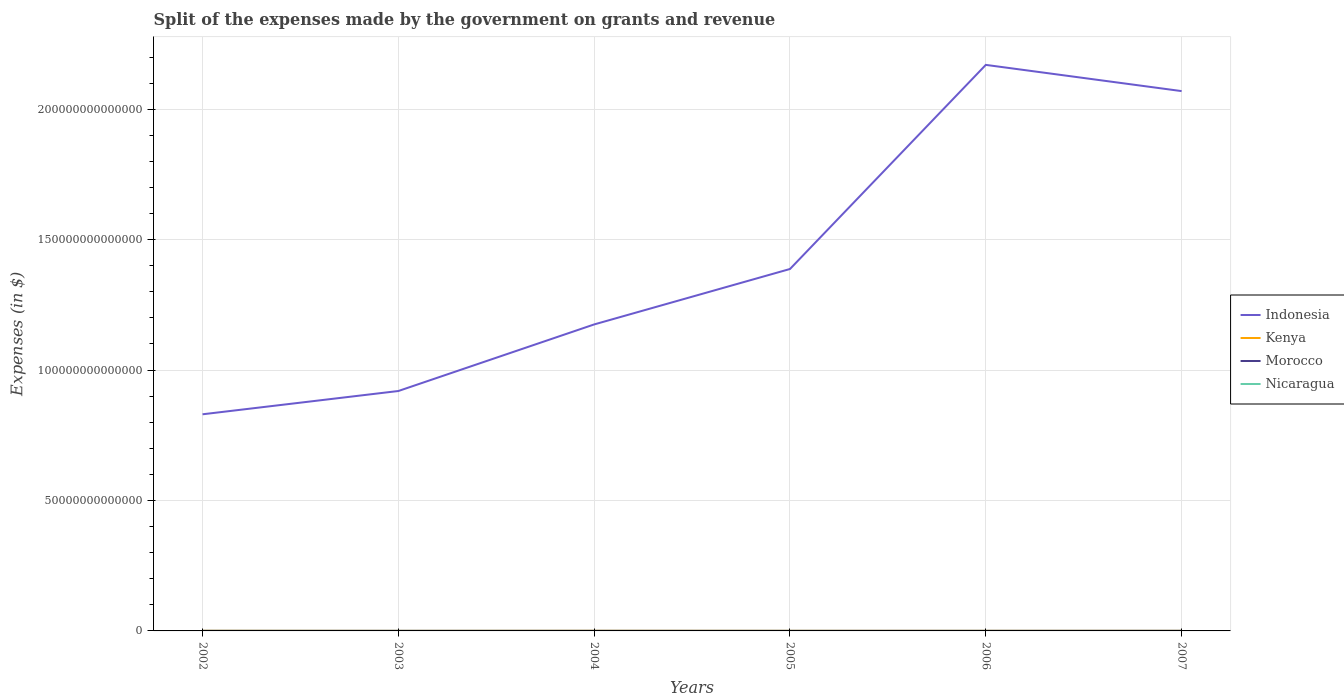How many different coloured lines are there?
Make the answer very short. 4. Does the line corresponding to Kenya intersect with the line corresponding to Nicaragua?
Offer a terse response. No. Across all years, what is the maximum expenses made by the government on grants and revenue in Morocco?
Your answer should be very brief. 2.56e+1. In which year was the expenses made by the government on grants and revenue in Nicaragua maximum?
Your answer should be compact. 2002. What is the total expenses made by the government on grants and revenue in Kenya in the graph?
Provide a succinct answer. 1.85e+1. What is the difference between the highest and the second highest expenses made by the government on grants and revenue in Indonesia?
Make the answer very short. 1.34e+14. What is the difference between the highest and the lowest expenses made by the government on grants and revenue in Nicaragua?
Offer a very short reply. 2. Is the expenses made by the government on grants and revenue in Kenya strictly greater than the expenses made by the government on grants and revenue in Nicaragua over the years?
Offer a terse response. No. How many lines are there?
Offer a very short reply. 4. What is the difference between two consecutive major ticks on the Y-axis?
Your response must be concise. 5.00e+13. What is the title of the graph?
Provide a succinct answer. Split of the expenses made by the government on grants and revenue. What is the label or title of the X-axis?
Keep it short and to the point. Years. What is the label or title of the Y-axis?
Your answer should be very brief. Expenses (in $). What is the Expenses (in $) in Indonesia in 2002?
Your response must be concise. 8.31e+13. What is the Expenses (in $) of Kenya in 2002?
Offer a very short reply. 5.49e+1. What is the Expenses (in $) in Morocco in 2002?
Your answer should be compact. 2.93e+1. What is the Expenses (in $) of Nicaragua in 2002?
Provide a succinct answer. 2.35e+09. What is the Expenses (in $) of Indonesia in 2003?
Provide a succinct answer. 9.20e+13. What is the Expenses (in $) of Kenya in 2003?
Your response must be concise. 2.51e+1. What is the Expenses (in $) in Morocco in 2003?
Provide a short and direct response. 2.68e+1. What is the Expenses (in $) of Nicaragua in 2003?
Your answer should be very brief. 2.81e+09. What is the Expenses (in $) of Indonesia in 2004?
Offer a very short reply. 1.17e+14. What is the Expenses (in $) in Kenya in 2004?
Make the answer very short. 5.44e+1. What is the Expenses (in $) of Morocco in 2004?
Your answer should be very brief. 3.17e+1. What is the Expenses (in $) in Nicaragua in 2004?
Provide a succinct answer. 3.35e+09. What is the Expenses (in $) in Indonesia in 2005?
Give a very brief answer. 1.39e+14. What is the Expenses (in $) of Kenya in 2005?
Ensure brevity in your answer.  3.64e+1. What is the Expenses (in $) of Morocco in 2005?
Your answer should be compact. 2.56e+1. What is the Expenses (in $) of Nicaragua in 2005?
Keep it short and to the point. 3.79e+09. What is the Expenses (in $) of Indonesia in 2006?
Ensure brevity in your answer.  2.17e+14. What is the Expenses (in $) of Kenya in 2006?
Make the answer very short. 3.59e+1. What is the Expenses (in $) of Morocco in 2006?
Your response must be concise. 3.04e+1. What is the Expenses (in $) in Nicaragua in 2006?
Provide a short and direct response. 4.94e+09. What is the Expenses (in $) in Indonesia in 2007?
Your answer should be compact. 2.07e+14. What is the Expenses (in $) of Kenya in 2007?
Make the answer very short. 3.28e+1. What is the Expenses (in $) of Morocco in 2007?
Make the answer very short. 3.32e+1. What is the Expenses (in $) in Nicaragua in 2007?
Make the answer very short. 5.51e+09. Across all years, what is the maximum Expenses (in $) of Indonesia?
Offer a terse response. 2.17e+14. Across all years, what is the maximum Expenses (in $) of Kenya?
Your response must be concise. 5.49e+1. Across all years, what is the maximum Expenses (in $) of Morocco?
Your answer should be compact. 3.32e+1. Across all years, what is the maximum Expenses (in $) of Nicaragua?
Offer a very short reply. 5.51e+09. Across all years, what is the minimum Expenses (in $) of Indonesia?
Your answer should be compact. 8.31e+13. Across all years, what is the minimum Expenses (in $) in Kenya?
Keep it short and to the point. 2.51e+1. Across all years, what is the minimum Expenses (in $) of Morocco?
Offer a terse response. 2.56e+1. Across all years, what is the minimum Expenses (in $) in Nicaragua?
Your response must be concise. 2.35e+09. What is the total Expenses (in $) in Indonesia in the graph?
Provide a succinct answer. 8.55e+14. What is the total Expenses (in $) of Kenya in the graph?
Your answer should be very brief. 2.40e+11. What is the total Expenses (in $) in Morocco in the graph?
Make the answer very short. 1.77e+11. What is the total Expenses (in $) of Nicaragua in the graph?
Make the answer very short. 2.27e+1. What is the difference between the Expenses (in $) in Indonesia in 2002 and that in 2003?
Keep it short and to the point. -8.92e+12. What is the difference between the Expenses (in $) in Kenya in 2002 and that in 2003?
Provide a succinct answer. 2.98e+1. What is the difference between the Expenses (in $) in Morocco in 2002 and that in 2003?
Provide a short and direct response. 2.50e+09. What is the difference between the Expenses (in $) in Nicaragua in 2002 and that in 2003?
Offer a terse response. -4.61e+08. What is the difference between the Expenses (in $) of Indonesia in 2002 and that in 2004?
Provide a short and direct response. -3.44e+13. What is the difference between the Expenses (in $) in Kenya in 2002 and that in 2004?
Offer a very short reply. 5.57e+08. What is the difference between the Expenses (in $) of Morocco in 2002 and that in 2004?
Provide a short and direct response. -2.42e+09. What is the difference between the Expenses (in $) of Nicaragua in 2002 and that in 2004?
Make the answer very short. -1.01e+09. What is the difference between the Expenses (in $) of Indonesia in 2002 and that in 2005?
Make the answer very short. -5.57e+13. What is the difference between the Expenses (in $) in Kenya in 2002 and that in 2005?
Provide a short and direct response. 1.85e+1. What is the difference between the Expenses (in $) of Morocco in 2002 and that in 2005?
Offer a terse response. 3.67e+09. What is the difference between the Expenses (in $) of Nicaragua in 2002 and that in 2005?
Offer a terse response. -1.44e+09. What is the difference between the Expenses (in $) of Indonesia in 2002 and that in 2006?
Offer a very short reply. -1.34e+14. What is the difference between the Expenses (in $) of Kenya in 2002 and that in 2006?
Give a very brief answer. 1.90e+1. What is the difference between the Expenses (in $) in Morocco in 2002 and that in 2006?
Provide a succinct answer. -1.04e+09. What is the difference between the Expenses (in $) in Nicaragua in 2002 and that in 2006?
Keep it short and to the point. -2.60e+09. What is the difference between the Expenses (in $) in Indonesia in 2002 and that in 2007?
Your response must be concise. -1.24e+14. What is the difference between the Expenses (in $) in Kenya in 2002 and that in 2007?
Offer a very short reply. 2.21e+1. What is the difference between the Expenses (in $) in Morocco in 2002 and that in 2007?
Provide a succinct answer. -3.87e+09. What is the difference between the Expenses (in $) in Nicaragua in 2002 and that in 2007?
Keep it short and to the point. -3.16e+09. What is the difference between the Expenses (in $) of Indonesia in 2003 and that in 2004?
Offer a very short reply. -2.55e+13. What is the difference between the Expenses (in $) in Kenya in 2003 and that in 2004?
Keep it short and to the point. -2.93e+1. What is the difference between the Expenses (in $) in Morocco in 2003 and that in 2004?
Ensure brevity in your answer.  -4.92e+09. What is the difference between the Expenses (in $) in Nicaragua in 2003 and that in 2004?
Give a very brief answer. -5.44e+08. What is the difference between the Expenses (in $) in Indonesia in 2003 and that in 2005?
Provide a succinct answer. -4.68e+13. What is the difference between the Expenses (in $) of Kenya in 2003 and that in 2005?
Offer a very short reply. -1.13e+1. What is the difference between the Expenses (in $) of Morocco in 2003 and that in 2005?
Your answer should be very brief. 1.17e+09. What is the difference between the Expenses (in $) in Nicaragua in 2003 and that in 2005?
Keep it short and to the point. -9.78e+08. What is the difference between the Expenses (in $) in Indonesia in 2003 and that in 2006?
Offer a very short reply. -1.25e+14. What is the difference between the Expenses (in $) in Kenya in 2003 and that in 2006?
Offer a terse response. -1.08e+1. What is the difference between the Expenses (in $) of Morocco in 2003 and that in 2006?
Give a very brief answer. -3.54e+09. What is the difference between the Expenses (in $) in Nicaragua in 2003 and that in 2006?
Offer a very short reply. -2.14e+09. What is the difference between the Expenses (in $) in Indonesia in 2003 and that in 2007?
Offer a very short reply. -1.15e+14. What is the difference between the Expenses (in $) of Kenya in 2003 and that in 2007?
Make the answer very short. -7.73e+09. What is the difference between the Expenses (in $) in Morocco in 2003 and that in 2007?
Make the answer very short. -6.37e+09. What is the difference between the Expenses (in $) of Nicaragua in 2003 and that in 2007?
Your response must be concise. -2.70e+09. What is the difference between the Expenses (in $) in Indonesia in 2004 and that in 2005?
Offer a very short reply. -2.13e+13. What is the difference between the Expenses (in $) of Kenya in 2004 and that in 2005?
Ensure brevity in your answer.  1.80e+1. What is the difference between the Expenses (in $) in Morocco in 2004 and that in 2005?
Offer a very short reply. 6.10e+09. What is the difference between the Expenses (in $) of Nicaragua in 2004 and that in 2005?
Provide a short and direct response. -4.34e+08. What is the difference between the Expenses (in $) of Indonesia in 2004 and that in 2006?
Give a very brief answer. -9.95e+13. What is the difference between the Expenses (in $) of Kenya in 2004 and that in 2006?
Your answer should be very brief. 1.85e+1. What is the difference between the Expenses (in $) of Morocco in 2004 and that in 2006?
Offer a very short reply. 1.38e+09. What is the difference between the Expenses (in $) in Nicaragua in 2004 and that in 2006?
Your answer should be compact. -1.59e+09. What is the difference between the Expenses (in $) in Indonesia in 2004 and that in 2007?
Offer a terse response. -8.95e+13. What is the difference between the Expenses (in $) in Kenya in 2004 and that in 2007?
Give a very brief answer. 2.15e+1. What is the difference between the Expenses (in $) in Morocco in 2004 and that in 2007?
Your answer should be compact. -1.44e+09. What is the difference between the Expenses (in $) of Nicaragua in 2004 and that in 2007?
Your answer should be very brief. -2.15e+09. What is the difference between the Expenses (in $) of Indonesia in 2005 and that in 2006?
Offer a terse response. -7.83e+13. What is the difference between the Expenses (in $) in Kenya in 2005 and that in 2006?
Offer a terse response. 5.04e+08. What is the difference between the Expenses (in $) of Morocco in 2005 and that in 2006?
Your response must be concise. -4.72e+09. What is the difference between the Expenses (in $) of Nicaragua in 2005 and that in 2006?
Ensure brevity in your answer.  -1.16e+09. What is the difference between the Expenses (in $) in Indonesia in 2005 and that in 2007?
Your answer should be compact. -6.82e+13. What is the difference between the Expenses (in $) in Kenya in 2005 and that in 2007?
Make the answer very short. 3.58e+09. What is the difference between the Expenses (in $) of Morocco in 2005 and that in 2007?
Offer a very short reply. -7.54e+09. What is the difference between the Expenses (in $) of Nicaragua in 2005 and that in 2007?
Provide a succinct answer. -1.72e+09. What is the difference between the Expenses (in $) in Indonesia in 2006 and that in 2007?
Offer a terse response. 1.01e+13. What is the difference between the Expenses (in $) of Kenya in 2006 and that in 2007?
Keep it short and to the point. 3.07e+09. What is the difference between the Expenses (in $) in Morocco in 2006 and that in 2007?
Ensure brevity in your answer.  -2.82e+09. What is the difference between the Expenses (in $) of Nicaragua in 2006 and that in 2007?
Make the answer very short. -5.64e+08. What is the difference between the Expenses (in $) of Indonesia in 2002 and the Expenses (in $) of Kenya in 2003?
Offer a terse response. 8.30e+13. What is the difference between the Expenses (in $) in Indonesia in 2002 and the Expenses (in $) in Morocco in 2003?
Offer a very short reply. 8.30e+13. What is the difference between the Expenses (in $) of Indonesia in 2002 and the Expenses (in $) of Nicaragua in 2003?
Make the answer very short. 8.30e+13. What is the difference between the Expenses (in $) in Kenya in 2002 and the Expenses (in $) in Morocco in 2003?
Your response must be concise. 2.81e+1. What is the difference between the Expenses (in $) in Kenya in 2002 and the Expenses (in $) in Nicaragua in 2003?
Provide a short and direct response. 5.21e+1. What is the difference between the Expenses (in $) of Morocco in 2002 and the Expenses (in $) of Nicaragua in 2003?
Give a very brief answer. 2.65e+1. What is the difference between the Expenses (in $) in Indonesia in 2002 and the Expenses (in $) in Kenya in 2004?
Keep it short and to the point. 8.30e+13. What is the difference between the Expenses (in $) in Indonesia in 2002 and the Expenses (in $) in Morocco in 2004?
Keep it short and to the point. 8.30e+13. What is the difference between the Expenses (in $) of Indonesia in 2002 and the Expenses (in $) of Nicaragua in 2004?
Your answer should be very brief. 8.30e+13. What is the difference between the Expenses (in $) of Kenya in 2002 and the Expenses (in $) of Morocco in 2004?
Make the answer very short. 2.32e+1. What is the difference between the Expenses (in $) in Kenya in 2002 and the Expenses (in $) in Nicaragua in 2004?
Your response must be concise. 5.16e+1. What is the difference between the Expenses (in $) in Morocco in 2002 and the Expenses (in $) in Nicaragua in 2004?
Your answer should be very brief. 2.60e+1. What is the difference between the Expenses (in $) of Indonesia in 2002 and the Expenses (in $) of Kenya in 2005?
Ensure brevity in your answer.  8.30e+13. What is the difference between the Expenses (in $) in Indonesia in 2002 and the Expenses (in $) in Morocco in 2005?
Ensure brevity in your answer.  8.30e+13. What is the difference between the Expenses (in $) of Indonesia in 2002 and the Expenses (in $) of Nicaragua in 2005?
Ensure brevity in your answer.  8.30e+13. What is the difference between the Expenses (in $) of Kenya in 2002 and the Expenses (in $) of Morocco in 2005?
Offer a terse response. 2.93e+1. What is the difference between the Expenses (in $) of Kenya in 2002 and the Expenses (in $) of Nicaragua in 2005?
Provide a short and direct response. 5.12e+1. What is the difference between the Expenses (in $) of Morocco in 2002 and the Expenses (in $) of Nicaragua in 2005?
Offer a terse response. 2.55e+1. What is the difference between the Expenses (in $) in Indonesia in 2002 and the Expenses (in $) in Kenya in 2006?
Offer a terse response. 8.30e+13. What is the difference between the Expenses (in $) of Indonesia in 2002 and the Expenses (in $) of Morocco in 2006?
Ensure brevity in your answer.  8.30e+13. What is the difference between the Expenses (in $) of Indonesia in 2002 and the Expenses (in $) of Nicaragua in 2006?
Your answer should be very brief. 8.30e+13. What is the difference between the Expenses (in $) of Kenya in 2002 and the Expenses (in $) of Morocco in 2006?
Your response must be concise. 2.46e+1. What is the difference between the Expenses (in $) of Kenya in 2002 and the Expenses (in $) of Nicaragua in 2006?
Provide a succinct answer. 5.00e+1. What is the difference between the Expenses (in $) in Morocco in 2002 and the Expenses (in $) in Nicaragua in 2006?
Give a very brief answer. 2.44e+1. What is the difference between the Expenses (in $) of Indonesia in 2002 and the Expenses (in $) of Kenya in 2007?
Provide a succinct answer. 8.30e+13. What is the difference between the Expenses (in $) in Indonesia in 2002 and the Expenses (in $) in Morocco in 2007?
Make the answer very short. 8.30e+13. What is the difference between the Expenses (in $) in Indonesia in 2002 and the Expenses (in $) in Nicaragua in 2007?
Offer a terse response. 8.30e+13. What is the difference between the Expenses (in $) of Kenya in 2002 and the Expenses (in $) of Morocco in 2007?
Give a very brief answer. 2.18e+1. What is the difference between the Expenses (in $) of Kenya in 2002 and the Expenses (in $) of Nicaragua in 2007?
Give a very brief answer. 4.94e+1. What is the difference between the Expenses (in $) of Morocco in 2002 and the Expenses (in $) of Nicaragua in 2007?
Your answer should be compact. 2.38e+1. What is the difference between the Expenses (in $) in Indonesia in 2003 and the Expenses (in $) in Kenya in 2004?
Ensure brevity in your answer.  9.19e+13. What is the difference between the Expenses (in $) of Indonesia in 2003 and the Expenses (in $) of Morocco in 2004?
Keep it short and to the point. 9.19e+13. What is the difference between the Expenses (in $) of Indonesia in 2003 and the Expenses (in $) of Nicaragua in 2004?
Ensure brevity in your answer.  9.20e+13. What is the difference between the Expenses (in $) of Kenya in 2003 and the Expenses (in $) of Morocco in 2004?
Offer a terse response. -6.63e+09. What is the difference between the Expenses (in $) of Kenya in 2003 and the Expenses (in $) of Nicaragua in 2004?
Provide a succinct answer. 2.18e+1. What is the difference between the Expenses (in $) of Morocco in 2003 and the Expenses (in $) of Nicaragua in 2004?
Make the answer very short. 2.35e+1. What is the difference between the Expenses (in $) of Indonesia in 2003 and the Expenses (in $) of Kenya in 2005?
Make the answer very short. 9.19e+13. What is the difference between the Expenses (in $) in Indonesia in 2003 and the Expenses (in $) in Morocco in 2005?
Offer a very short reply. 9.19e+13. What is the difference between the Expenses (in $) of Indonesia in 2003 and the Expenses (in $) of Nicaragua in 2005?
Your answer should be very brief. 9.20e+13. What is the difference between the Expenses (in $) of Kenya in 2003 and the Expenses (in $) of Morocco in 2005?
Ensure brevity in your answer.  -5.30e+08. What is the difference between the Expenses (in $) of Kenya in 2003 and the Expenses (in $) of Nicaragua in 2005?
Make the answer very short. 2.13e+1. What is the difference between the Expenses (in $) in Morocco in 2003 and the Expenses (in $) in Nicaragua in 2005?
Offer a terse response. 2.30e+1. What is the difference between the Expenses (in $) of Indonesia in 2003 and the Expenses (in $) of Kenya in 2006?
Provide a short and direct response. 9.19e+13. What is the difference between the Expenses (in $) of Indonesia in 2003 and the Expenses (in $) of Morocco in 2006?
Keep it short and to the point. 9.19e+13. What is the difference between the Expenses (in $) of Indonesia in 2003 and the Expenses (in $) of Nicaragua in 2006?
Your response must be concise. 9.20e+13. What is the difference between the Expenses (in $) of Kenya in 2003 and the Expenses (in $) of Morocco in 2006?
Offer a very short reply. -5.25e+09. What is the difference between the Expenses (in $) in Kenya in 2003 and the Expenses (in $) in Nicaragua in 2006?
Provide a short and direct response. 2.02e+1. What is the difference between the Expenses (in $) in Morocco in 2003 and the Expenses (in $) in Nicaragua in 2006?
Make the answer very short. 2.19e+1. What is the difference between the Expenses (in $) in Indonesia in 2003 and the Expenses (in $) in Kenya in 2007?
Give a very brief answer. 9.19e+13. What is the difference between the Expenses (in $) in Indonesia in 2003 and the Expenses (in $) in Morocco in 2007?
Offer a terse response. 9.19e+13. What is the difference between the Expenses (in $) of Indonesia in 2003 and the Expenses (in $) of Nicaragua in 2007?
Provide a short and direct response. 9.20e+13. What is the difference between the Expenses (in $) of Kenya in 2003 and the Expenses (in $) of Morocco in 2007?
Provide a succinct answer. -8.07e+09. What is the difference between the Expenses (in $) in Kenya in 2003 and the Expenses (in $) in Nicaragua in 2007?
Your answer should be very brief. 1.96e+1. What is the difference between the Expenses (in $) of Morocco in 2003 and the Expenses (in $) of Nicaragua in 2007?
Your answer should be compact. 2.13e+1. What is the difference between the Expenses (in $) of Indonesia in 2004 and the Expenses (in $) of Kenya in 2005?
Make the answer very short. 1.17e+14. What is the difference between the Expenses (in $) of Indonesia in 2004 and the Expenses (in $) of Morocco in 2005?
Your response must be concise. 1.17e+14. What is the difference between the Expenses (in $) in Indonesia in 2004 and the Expenses (in $) in Nicaragua in 2005?
Make the answer very short. 1.17e+14. What is the difference between the Expenses (in $) in Kenya in 2004 and the Expenses (in $) in Morocco in 2005?
Give a very brief answer. 2.88e+1. What is the difference between the Expenses (in $) in Kenya in 2004 and the Expenses (in $) in Nicaragua in 2005?
Offer a terse response. 5.06e+1. What is the difference between the Expenses (in $) in Morocco in 2004 and the Expenses (in $) in Nicaragua in 2005?
Offer a very short reply. 2.80e+1. What is the difference between the Expenses (in $) of Indonesia in 2004 and the Expenses (in $) of Kenya in 2006?
Provide a succinct answer. 1.17e+14. What is the difference between the Expenses (in $) of Indonesia in 2004 and the Expenses (in $) of Morocco in 2006?
Provide a short and direct response. 1.17e+14. What is the difference between the Expenses (in $) of Indonesia in 2004 and the Expenses (in $) of Nicaragua in 2006?
Offer a very short reply. 1.17e+14. What is the difference between the Expenses (in $) in Kenya in 2004 and the Expenses (in $) in Morocco in 2006?
Make the answer very short. 2.40e+1. What is the difference between the Expenses (in $) in Kenya in 2004 and the Expenses (in $) in Nicaragua in 2006?
Your response must be concise. 4.94e+1. What is the difference between the Expenses (in $) in Morocco in 2004 and the Expenses (in $) in Nicaragua in 2006?
Make the answer very short. 2.68e+1. What is the difference between the Expenses (in $) of Indonesia in 2004 and the Expenses (in $) of Kenya in 2007?
Offer a terse response. 1.17e+14. What is the difference between the Expenses (in $) of Indonesia in 2004 and the Expenses (in $) of Morocco in 2007?
Ensure brevity in your answer.  1.17e+14. What is the difference between the Expenses (in $) in Indonesia in 2004 and the Expenses (in $) in Nicaragua in 2007?
Your answer should be compact. 1.17e+14. What is the difference between the Expenses (in $) in Kenya in 2004 and the Expenses (in $) in Morocco in 2007?
Offer a terse response. 2.12e+1. What is the difference between the Expenses (in $) of Kenya in 2004 and the Expenses (in $) of Nicaragua in 2007?
Give a very brief answer. 4.89e+1. What is the difference between the Expenses (in $) of Morocco in 2004 and the Expenses (in $) of Nicaragua in 2007?
Your response must be concise. 2.62e+1. What is the difference between the Expenses (in $) in Indonesia in 2005 and the Expenses (in $) in Kenya in 2006?
Offer a terse response. 1.39e+14. What is the difference between the Expenses (in $) in Indonesia in 2005 and the Expenses (in $) in Morocco in 2006?
Keep it short and to the point. 1.39e+14. What is the difference between the Expenses (in $) of Indonesia in 2005 and the Expenses (in $) of Nicaragua in 2006?
Ensure brevity in your answer.  1.39e+14. What is the difference between the Expenses (in $) in Kenya in 2005 and the Expenses (in $) in Morocco in 2006?
Offer a very short reply. 6.06e+09. What is the difference between the Expenses (in $) in Kenya in 2005 and the Expenses (in $) in Nicaragua in 2006?
Offer a terse response. 3.15e+1. What is the difference between the Expenses (in $) in Morocco in 2005 and the Expenses (in $) in Nicaragua in 2006?
Offer a very short reply. 2.07e+1. What is the difference between the Expenses (in $) of Indonesia in 2005 and the Expenses (in $) of Kenya in 2007?
Give a very brief answer. 1.39e+14. What is the difference between the Expenses (in $) of Indonesia in 2005 and the Expenses (in $) of Morocco in 2007?
Ensure brevity in your answer.  1.39e+14. What is the difference between the Expenses (in $) in Indonesia in 2005 and the Expenses (in $) in Nicaragua in 2007?
Your answer should be compact. 1.39e+14. What is the difference between the Expenses (in $) in Kenya in 2005 and the Expenses (in $) in Morocco in 2007?
Give a very brief answer. 3.24e+09. What is the difference between the Expenses (in $) in Kenya in 2005 and the Expenses (in $) in Nicaragua in 2007?
Offer a very short reply. 3.09e+1. What is the difference between the Expenses (in $) of Morocco in 2005 and the Expenses (in $) of Nicaragua in 2007?
Give a very brief answer. 2.01e+1. What is the difference between the Expenses (in $) in Indonesia in 2006 and the Expenses (in $) in Kenya in 2007?
Your response must be concise. 2.17e+14. What is the difference between the Expenses (in $) of Indonesia in 2006 and the Expenses (in $) of Morocco in 2007?
Ensure brevity in your answer.  2.17e+14. What is the difference between the Expenses (in $) of Indonesia in 2006 and the Expenses (in $) of Nicaragua in 2007?
Ensure brevity in your answer.  2.17e+14. What is the difference between the Expenses (in $) in Kenya in 2006 and the Expenses (in $) in Morocco in 2007?
Your answer should be very brief. 2.74e+09. What is the difference between the Expenses (in $) in Kenya in 2006 and the Expenses (in $) in Nicaragua in 2007?
Make the answer very short. 3.04e+1. What is the difference between the Expenses (in $) in Morocco in 2006 and the Expenses (in $) in Nicaragua in 2007?
Your response must be concise. 2.49e+1. What is the average Expenses (in $) of Indonesia per year?
Provide a succinct answer. 1.43e+14. What is the average Expenses (in $) in Kenya per year?
Offer a terse response. 3.99e+1. What is the average Expenses (in $) of Morocco per year?
Your answer should be compact. 2.95e+1. What is the average Expenses (in $) of Nicaragua per year?
Give a very brief answer. 3.79e+09. In the year 2002, what is the difference between the Expenses (in $) of Indonesia and Expenses (in $) of Kenya?
Provide a short and direct response. 8.30e+13. In the year 2002, what is the difference between the Expenses (in $) of Indonesia and Expenses (in $) of Morocco?
Provide a succinct answer. 8.30e+13. In the year 2002, what is the difference between the Expenses (in $) of Indonesia and Expenses (in $) of Nicaragua?
Provide a succinct answer. 8.30e+13. In the year 2002, what is the difference between the Expenses (in $) in Kenya and Expenses (in $) in Morocco?
Your response must be concise. 2.56e+1. In the year 2002, what is the difference between the Expenses (in $) in Kenya and Expenses (in $) in Nicaragua?
Provide a short and direct response. 5.26e+1. In the year 2002, what is the difference between the Expenses (in $) of Morocco and Expenses (in $) of Nicaragua?
Your answer should be very brief. 2.70e+1. In the year 2003, what is the difference between the Expenses (in $) of Indonesia and Expenses (in $) of Kenya?
Your response must be concise. 9.19e+13. In the year 2003, what is the difference between the Expenses (in $) of Indonesia and Expenses (in $) of Morocco?
Your response must be concise. 9.19e+13. In the year 2003, what is the difference between the Expenses (in $) in Indonesia and Expenses (in $) in Nicaragua?
Offer a very short reply. 9.20e+13. In the year 2003, what is the difference between the Expenses (in $) of Kenya and Expenses (in $) of Morocco?
Provide a succinct answer. -1.70e+09. In the year 2003, what is the difference between the Expenses (in $) of Kenya and Expenses (in $) of Nicaragua?
Offer a very short reply. 2.23e+1. In the year 2003, what is the difference between the Expenses (in $) in Morocco and Expenses (in $) in Nicaragua?
Ensure brevity in your answer.  2.40e+1. In the year 2004, what is the difference between the Expenses (in $) in Indonesia and Expenses (in $) in Kenya?
Your response must be concise. 1.17e+14. In the year 2004, what is the difference between the Expenses (in $) in Indonesia and Expenses (in $) in Morocco?
Ensure brevity in your answer.  1.17e+14. In the year 2004, what is the difference between the Expenses (in $) in Indonesia and Expenses (in $) in Nicaragua?
Your answer should be compact. 1.17e+14. In the year 2004, what is the difference between the Expenses (in $) of Kenya and Expenses (in $) of Morocco?
Offer a terse response. 2.27e+1. In the year 2004, what is the difference between the Expenses (in $) of Kenya and Expenses (in $) of Nicaragua?
Your answer should be very brief. 5.10e+1. In the year 2004, what is the difference between the Expenses (in $) in Morocco and Expenses (in $) in Nicaragua?
Offer a terse response. 2.84e+1. In the year 2005, what is the difference between the Expenses (in $) of Indonesia and Expenses (in $) of Kenya?
Give a very brief answer. 1.39e+14. In the year 2005, what is the difference between the Expenses (in $) of Indonesia and Expenses (in $) of Morocco?
Offer a very short reply. 1.39e+14. In the year 2005, what is the difference between the Expenses (in $) of Indonesia and Expenses (in $) of Nicaragua?
Make the answer very short. 1.39e+14. In the year 2005, what is the difference between the Expenses (in $) of Kenya and Expenses (in $) of Morocco?
Offer a terse response. 1.08e+1. In the year 2005, what is the difference between the Expenses (in $) of Kenya and Expenses (in $) of Nicaragua?
Provide a succinct answer. 3.26e+1. In the year 2005, what is the difference between the Expenses (in $) in Morocco and Expenses (in $) in Nicaragua?
Ensure brevity in your answer.  2.19e+1. In the year 2006, what is the difference between the Expenses (in $) of Indonesia and Expenses (in $) of Kenya?
Provide a succinct answer. 2.17e+14. In the year 2006, what is the difference between the Expenses (in $) in Indonesia and Expenses (in $) in Morocco?
Provide a succinct answer. 2.17e+14. In the year 2006, what is the difference between the Expenses (in $) in Indonesia and Expenses (in $) in Nicaragua?
Your answer should be compact. 2.17e+14. In the year 2006, what is the difference between the Expenses (in $) of Kenya and Expenses (in $) of Morocco?
Make the answer very short. 5.56e+09. In the year 2006, what is the difference between the Expenses (in $) of Kenya and Expenses (in $) of Nicaragua?
Make the answer very short. 3.10e+1. In the year 2006, what is the difference between the Expenses (in $) in Morocco and Expenses (in $) in Nicaragua?
Your response must be concise. 2.54e+1. In the year 2007, what is the difference between the Expenses (in $) in Indonesia and Expenses (in $) in Kenya?
Keep it short and to the point. 2.07e+14. In the year 2007, what is the difference between the Expenses (in $) of Indonesia and Expenses (in $) of Morocco?
Your response must be concise. 2.07e+14. In the year 2007, what is the difference between the Expenses (in $) in Indonesia and Expenses (in $) in Nicaragua?
Give a very brief answer. 2.07e+14. In the year 2007, what is the difference between the Expenses (in $) in Kenya and Expenses (in $) in Morocco?
Your answer should be very brief. -3.38e+08. In the year 2007, what is the difference between the Expenses (in $) of Kenya and Expenses (in $) of Nicaragua?
Offer a very short reply. 2.73e+1. In the year 2007, what is the difference between the Expenses (in $) of Morocco and Expenses (in $) of Nicaragua?
Ensure brevity in your answer.  2.77e+1. What is the ratio of the Expenses (in $) in Indonesia in 2002 to that in 2003?
Keep it short and to the point. 0.9. What is the ratio of the Expenses (in $) in Kenya in 2002 to that in 2003?
Make the answer very short. 2.19. What is the ratio of the Expenses (in $) of Morocco in 2002 to that in 2003?
Your response must be concise. 1.09. What is the ratio of the Expenses (in $) in Nicaragua in 2002 to that in 2003?
Your response must be concise. 0.84. What is the ratio of the Expenses (in $) in Indonesia in 2002 to that in 2004?
Give a very brief answer. 0.71. What is the ratio of the Expenses (in $) of Kenya in 2002 to that in 2004?
Your response must be concise. 1.01. What is the ratio of the Expenses (in $) in Morocco in 2002 to that in 2004?
Provide a succinct answer. 0.92. What is the ratio of the Expenses (in $) of Nicaragua in 2002 to that in 2004?
Your response must be concise. 0.7. What is the ratio of the Expenses (in $) of Indonesia in 2002 to that in 2005?
Give a very brief answer. 0.6. What is the ratio of the Expenses (in $) of Kenya in 2002 to that in 2005?
Your answer should be very brief. 1.51. What is the ratio of the Expenses (in $) in Morocco in 2002 to that in 2005?
Ensure brevity in your answer.  1.14. What is the ratio of the Expenses (in $) in Nicaragua in 2002 to that in 2005?
Give a very brief answer. 0.62. What is the ratio of the Expenses (in $) of Indonesia in 2002 to that in 2006?
Offer a terse response. 0.38. What is the ratio of the Expenses (in $) in Kenya in 2002 to that in 2006?
Make the answer very short. 1.53. What is the ratio of the Expenses (in $) in Morocco in 2002 to that in 2006?
Offer a terse response. 0.97. What is the ratio of the Expenses (in $) of Nicaragua in 2002 to that in 2006?
Your response must be concise. 0.47. What is the ratio of the Expenses (in $) of Indonesia in 2002 to that in 2007?
Provide a short and direct response. 0.4. What is the ratio of the Expenses (in $) of Kenya in 2002 to that in 2007?
Your answer should be very brief. 1.67. What is the ratio of the Expenses (in $) of Morocco in 2002 to that in 2007?
Offer a terse response. 0.88. What is the ratio of the Expenses (in $) in Nicaragua in 2002 to that in 2007?
Offer a terse response. 0.43. What is the ratio of the Expenses (in $) in Indonesia in 2003 to that in 2004?
Give a very brief answer. 0.78. What is the ratio of the Expenses (in $) of Kenya in 2003 to that in 2004?
Provide a succinct answer. 0.46. What is the ratio of the Expenses (in $) of Morocco in 2003 to that in 2004?
Ensure brevity in your answer.  0.84. What is the ratio of the Expenses (in $) in Nicaragua in 2003 to that in 2004?
Your answer should be very brief. 0.84. What is the ratio of the Expenses (in $) in Indonesia in 2003 to that in 2005?
Make the answer very short. 0.66. What is the ratio of the Expenses (in $) of Kenya in 2003 to that in 2005?
Your response must be concise. 0.69. What is the ratio of the Expenses (in $) in Morocco in 2003 to that in 2005?
Give a very brief answer. 1.05. What is the ratio of the Expenses (in $) in Nicaragua in 2003 to that in 2005?
Give a very brief answer. 0.74. What is the ratio of the Expenses (in $) in Indonesia in 2003 to that in 2006?
Keep it short and to the point. 0.42. What is the ratio of the Expenses (in $) of Kenya in 2003 to that in 2006?
Give a very brief answer. 0.7. What is the ratio of the Expenses (in $) in Morocco in 2003 to that in 2006?
Offer a terse response. 0.88. What is the ratio of the Expenses (in $) in Nicaragua in 2003 to that in 2006?
Offer a very short reply. 0.57. What is the ratio of the Expenses (in $) in Indonesia in 2003 to that in 2007?
Provide a short and direct response. 0.44. What is the ratio of the Expenses (in $) of Kenya in 2003 to that in 2007?
Your answer should be compact. 0.76. What is the ratio of the Expenses (in $) of Morocco in 2003 to that in 2007?
Offer a very short reply. 0.81. What is the ratio of the Expenses (in $) in Nicaragua in 2003 to that in 2007?
Give a very brief answer. 0.51. What is the ratio of the Expenses (in $) of Indonesia in 2004 to that in 2005?
Your response must be concise. 0.85. What is the ratio of the Expenses (in $) in Kenya in 2004 to that in 2005?
Your answer should be compact. 1.49. What is the ratio of the Expenses (in $) of Morocco in 2004 to that in 2005?
Your answer should be compact. 1.24. What is the ratio of the Expenses (in $) of Nicaragua in 2004 to that in 2005?
Your response must be concise. 0.89. What is the ratio of the Expenses (in $) of Indonesia in 2004 to that in 2006?
Keep it short and to the point. 0.54. What is the ratio of the Expenses (in $) of Kenya in 2004 to that in 2006?
Offer a very short reply. 1.51. What is the ratio of the Expenses (in $) in Morocco in 2004 to that in 2006?
Make the answer very short. 1.05. What is the ratio of the Expenses (in $) of Nicaragua in 2004 to that in 2006?
Your response must be concise. 0.68. What is the ratio of the Expenses (in $) in Indonesia in 2004 to that in 2007?
Keep it short and to the point. 0.57. What is the ratio of the Expenses (in $) in Kenya in 2004 to that in 2007?
Offer a very short reply. 1.66. What is the ratio of the Expenses (in $) of Morocco in 2004 to that in 2007?
Your answer should be very brief. 0.96. What is the ratio of the Expenses (in $) of Nicaragua in 2004 to that in 2007?
Keep it short and to the point. 0.61. What is the ratio of the Expenses (in $) of Indonesia in 2005 to that in 2006?
Make the answer very short. 0.64. What is the ratio of the Expenses (in $) in Morocco in 2005 to that in 2006?
Ensure brevity in your answer.  0.84. What is the ratio of the Expenses (in $) of Nicaragua in 2005 to that in 2006?
Your answer should be very brief. 0.77. What is the ratio of the Expenses (in $) of Indonesia in 2005 to that in 2007?
Give a very brief answer. 0.67. What is the ratio of the Expenses (in $) in Kenya in 2005 to that in 2007?
Offer a terse response. 1.11. What is the ratio of the Expenses (in $) in Morocco in 2005 to that in 2007?
Offer a very short reply. 0.77. What is the ratio of the Expenses (in $) of Nicaragua in 2005 to that in 2007?
Keep it short and to the point. 0.69. What is the ratio of the Expenses (in $) of Indonesia in 2006 to that in 2007?
Provide a short and direct response. 1.05. What is the ratio of the Expenses (in $) of Kenya in 2006 to that in 2007?
Offer a very short reply. 1.09. What is the ratio of the Expenses (in $) in Morocco in 2006 to that in 2007?
Your answer should be very brief. 0.91. What is the ratio of the Expenses (in $) in Nicaragua in 2006 to that in 2007?
Your answer should be compact. 0.9. What is the difference between the highest and the second highest Expenses (in $) in Indonesia?
Ensure brevity in your answer.  1.01e+13. What is the difference between the highest and the second highest Expenses (in $) in Kenya?
Provide a succinct answer. 5.57e+08. What is the difference between the highest and the second highest Expenses (in $) in Morocco?
Offer a terse response. 1.44e+09. What is the difference between the highest and the second highest Expenses (in $) in Nicaragua?
Your answer should be compact. 5.64e+08. What is the difference between the highest and the lowest Expenses (in $) of Indonesia?
Provide a short and direct response. 1.34e+14. What is the difference between the highest and the lowest Expenses (in $) in Kenya?
Provide a short and direct response. 2.98e+1. What is the difference between the highest and the lowest Expenses (in $) in Morocco?
Ensure brevity in your answer.  7.54e+09. What is the difference between the highest and the lowest Expenses (in $) of Nicaragua?
Keep it short and to the point. 3.16e+09. 